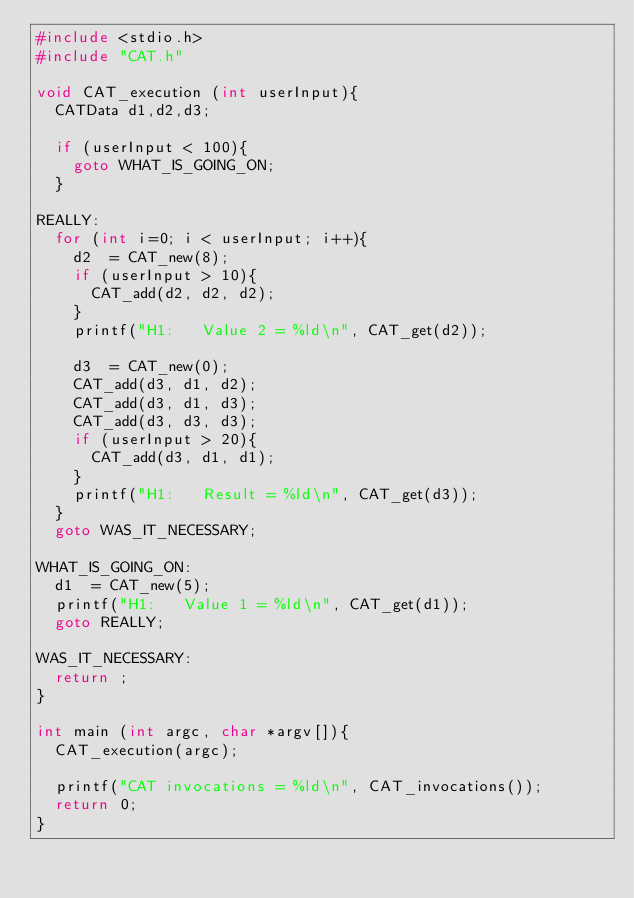<code> <loc_0><loc_0><loc_500><loc_500><_C_>#include <stdio.h>
#include "CAT.h"

void CAT_execution (int userInput){
	CATData	d1,d2,d3;

  if (userInput < 100){
    goto WHAT_IS_GOING_ON;
  }

REALLY:
  for (int i=0; i < userInput; i++){
    d2	= CAT_new(8);
    if (userInput > 10){
	    CAT_add(d2, d2, d2);
    }
	  printf("H1: 	Value 2 = %ld\n", CAT_get(d2));

	  d3	= CAT_new(0);
	  CAT_add(d3, d1, d2);
	  CAT_add(d3, d1, d3);
	  CAT_add(d3, d3, d3);
    if (userInput > 20){
	    CAT_add(d3, d1, d1);
    }
	  printf("H1: 	Result = %ld\n", CAT_get(d3));
  }
  goto WAS_IT_NECESSARY;

WHAT_IS_GOING_ON:
	d1	= CAT_new(5);
	printf("H1: 	Value 1 = %ld\n", CAT_get(d1));
  goto REALLY;

WAS_IT_NECESSARY:
	return ;
}

int main (int argc, char *argv[]){
	CAT_execution(argc);

  printf("CAT invocations = %ld\n", CAT_invocations());
	return 0;
}
</code> 